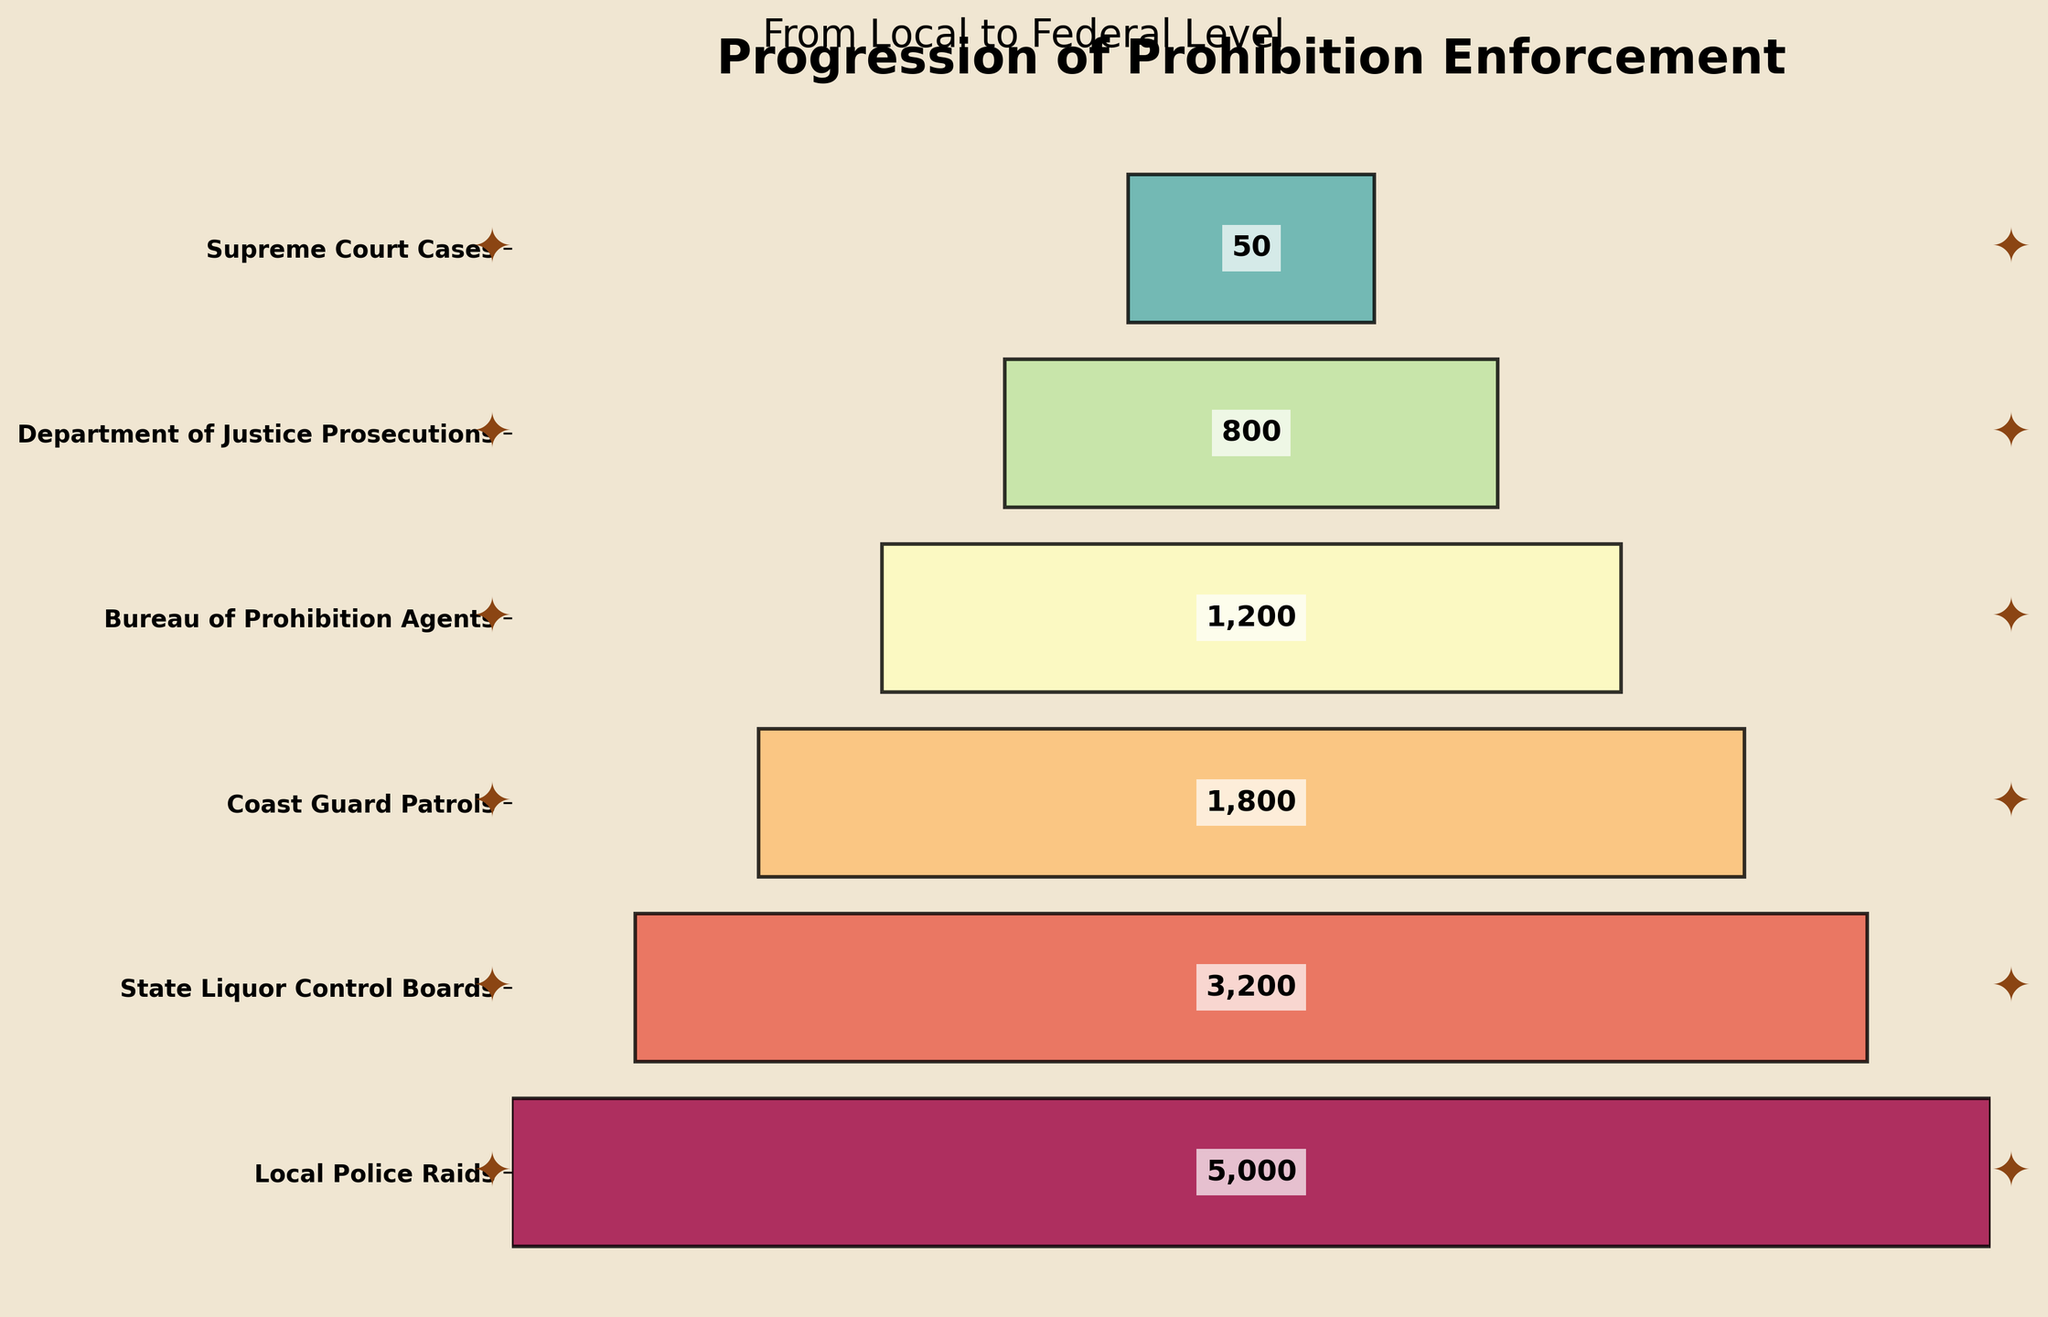What's the title of the funnel chart? The title of the funnel chart is typically found at the top of the figure and in this case reads "Progression of Prohibition Enforcement".
Answer: Progression of Prohibition Enforcement How many enforcement stages are depicted in the funnel chart? Each stage is represented by a bar segment in the funnel chart. By counting them, we see there are six stages.
Answer: Six Which stage has the highest number of actions? The width of the bar segments indicates the number of actions. The widest bar segment represents "Local Police Raids" with 5000 actions.
Answer: Local Police Raids What's the difference in the number of actions between Coast Guard Patrols and Bureau of Prohibition Agents? The chart shows that Coast Guard Patrols have 1800 actions and Bureau of Prohibition Agents have 1200 actions. The difference is calculated as 1800 - 1200 = 600.
Answer: 600 What is the sum of actions taken at the Federal level stages? Adding the actions at the Federal level stages gives us 1200 (Bureau of Prohibition Agents) + 800 (Department of Justice Prosecutions) + 50 (Supreme Court Cases) = 2050.
Answer: 2050 How does the number of state-level enforcement actions compare to regional-level actions? From the funnel chart, State Liquor Control Boards have 3200 actions, and Coast Guard Patrols have 1800 actions. State-level actions are higher.
Answer: State-level actions are higher Which enforcement level has the least number of actions? The narrowest bar segment represents the enforcement level with the least number of actions. "Supreme Court Cases" at the Federal level has 50 actions.
Answer: Supreme Court Cases What is the percentage decrease from Municipal to State enforcement levels? The chart shows 5000 actions at the Municipal level and 3200 at the State level. The percentage decrease is calculated as ((5000 - 3200) / 5000) * 100 = 36%.
Answer: 36% Arrange the enforcement levels in ascending order of actions taken. By looking at the chart's bar segments from narrowest to widest: Supreme Court Cases (50), Department of Justice Prosecutions (800), Bureau of Prohibition Agents (1200), Coast Guard Patrols (1800), State Liquor Control Boards (3200), Local Police Raids (5000).
Answer: Supreme Court Cases, Department of Justice Prosecutions, Bureau of Prohibition Agents, Coast Guard Patrols, State Liquor Control Boards, Local Police Raids What is the color gradient used in the funnel chart? The bar segments use a color gradient from the 'Spectral' colormap, ranging from light to dark across the stages.
Answer: Spectral colormap 